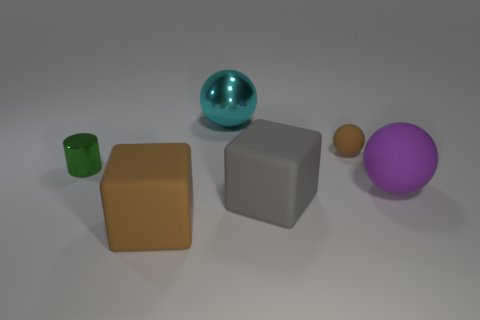Add 3 big balls. How many objects exist? 9 Subtract all cylinders. How many objects are left? 5 Subtract 1 cyan balls. How many objects are left? 5 Subtract all big purple rubber things. Subtract all purple spheres. How many objects are left? 4 Add 5 green metal cylinders. How many green metal cylinders are left? 6 Add 2 blocks. How many blocks exist? 4 